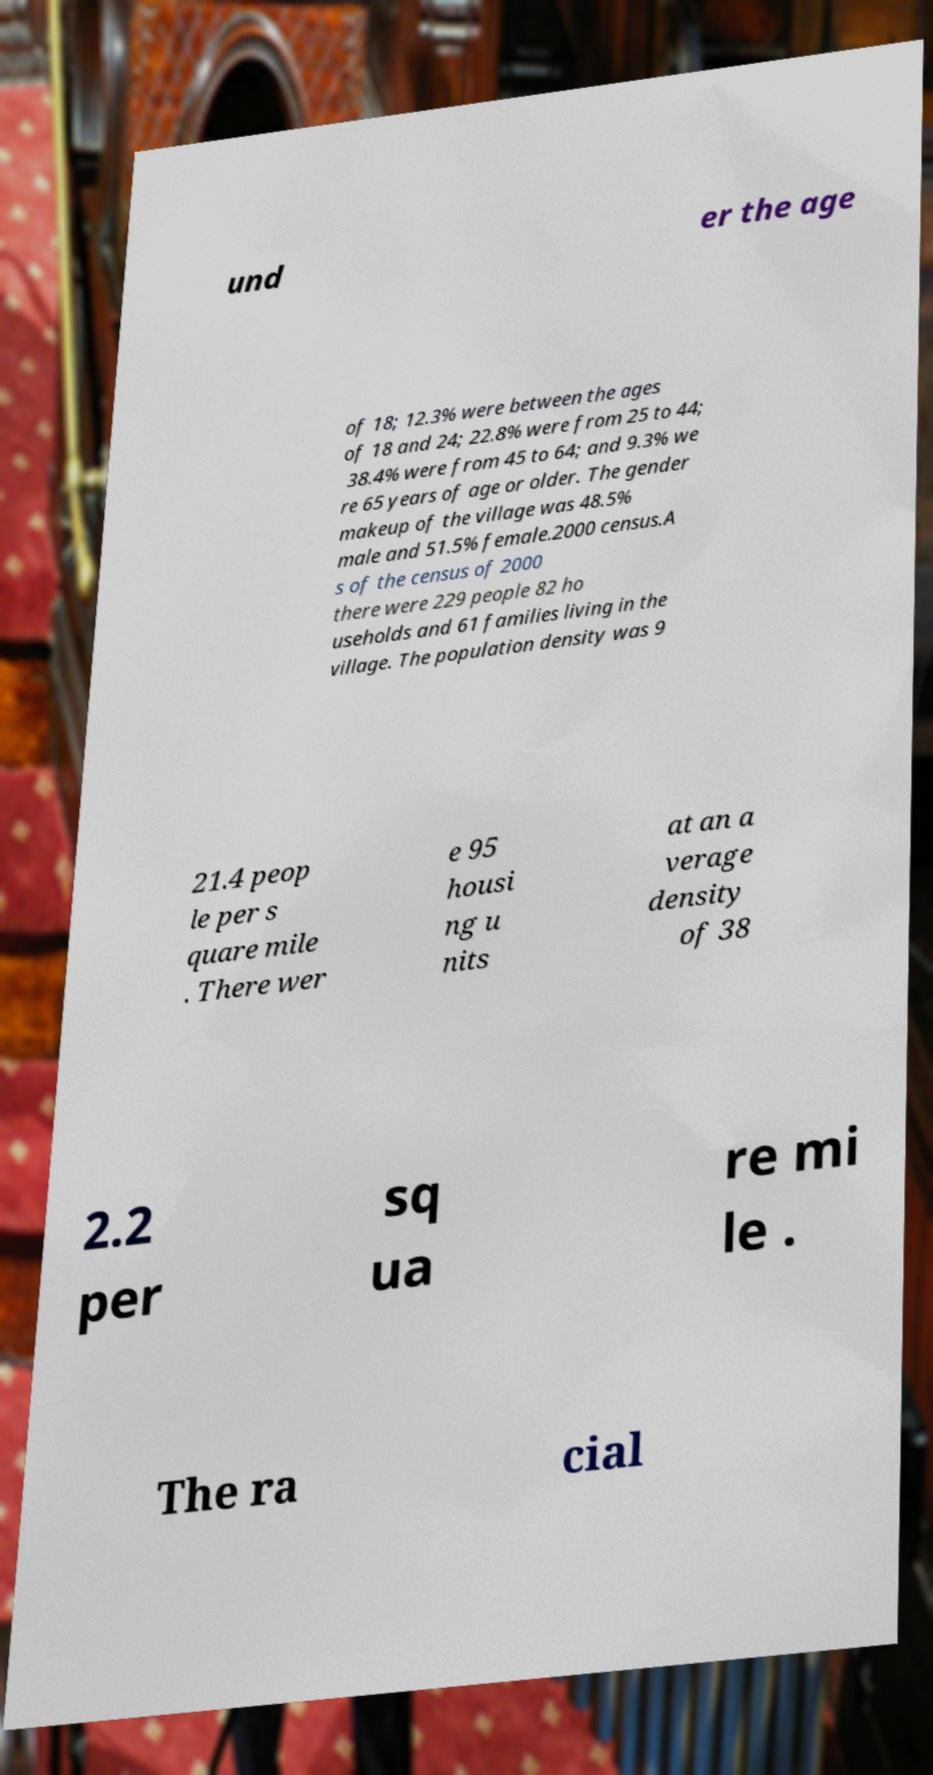What messages or text are displayed in this image? I need them in a readable, typed format. und er the age of 18; 12.3% were between the ages of 18 and 24; 22.8% were from 25 to 44; 38.4% were from 45 to 64; and 9.3% we re 65 years of age or older. The gender makeup of the village was 48.5% male and 51.5% female.2000 census.A s of the census of 2000 there were 229 people 82 ho useholds and 61 families living in the village. The population density was 9 21.4 peop le per s quare mile . There wer e 95 housi ng u nits at an a verage density of 38 2.2 per sq ua re mi le . The ra cial 